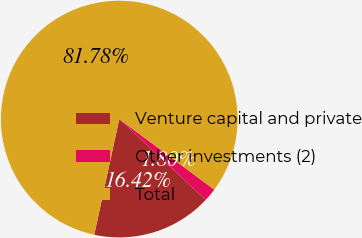Convert chart. <chart><loc_0><loc_0><loc_500><loc_500><pie_chart><fcel>Venture capital and private<fcel>Other investments (2)<fcel>Total<nl><fcel>16.42%<fcel>1.8%<fcel>81.78%<nl></chart> 